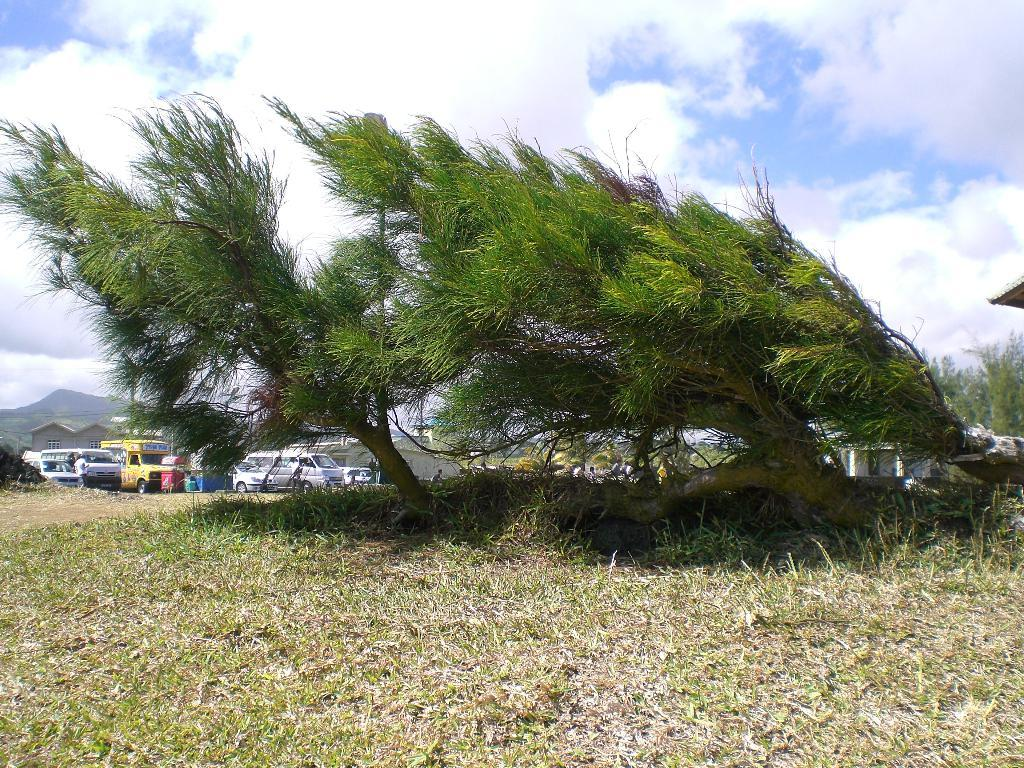What type of terrain is visible in the image? The ground with grass is visible in the image. What other natural elements can be seen in the image? There are plants and mountains visible in the image. What man-made structures are present in the image? Houses are present in the image. What is the weather like in the image? The sky is visible in the image, and clouds are present, suggesting a partly cloudy day. Can you tell me how many people are swimming in the image? There is no swimming activity depicted in the image; people are present, but they are not swimming. What type of print can be seen on the mountains in the image? There is no print or design on the mountains in the image; they are natural formations. 